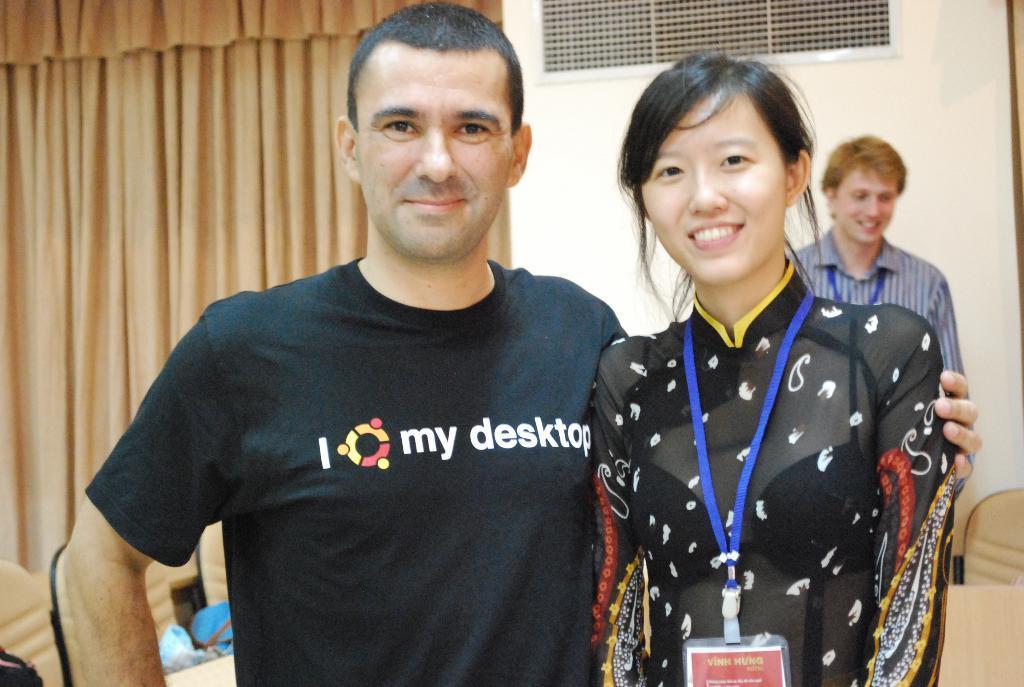How would you summarize this image in a sentence or two? In this image in the foreground there is one man and one woman who are standing and they are smiling, in the background there is another man and on the left side there is a curtain. And on the top of the image there is a wall and some window, and at the bottom there are some chairs. 